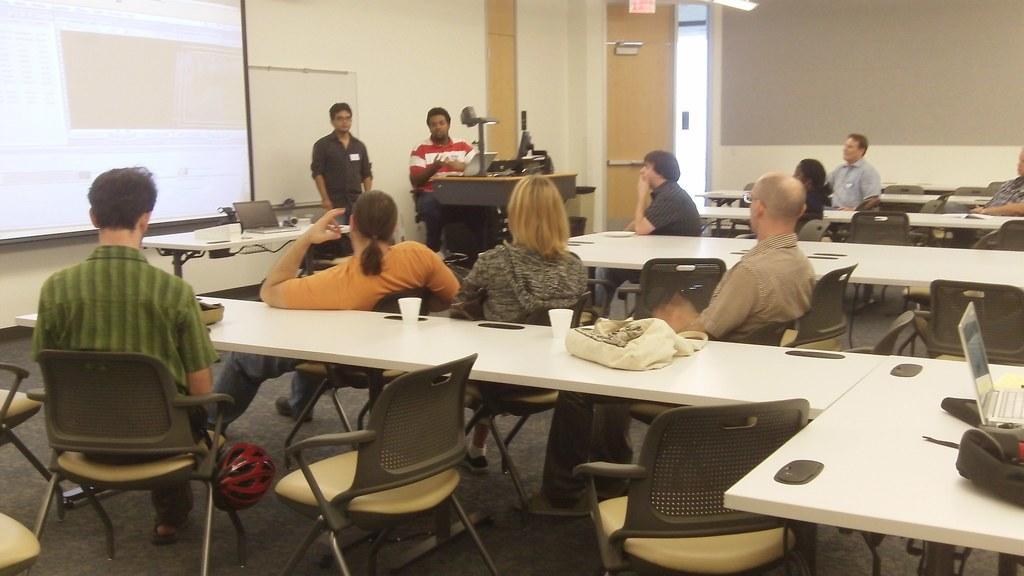Could you give a brief overview of what you see in this image? This is a conference room. Here we can see few persons sitting on chairs near to the table and on the table we can see laptops, bags, glasses. This is a screen. Near to the screen we can see two persons. This is a floor. This is a helmet in red color. 